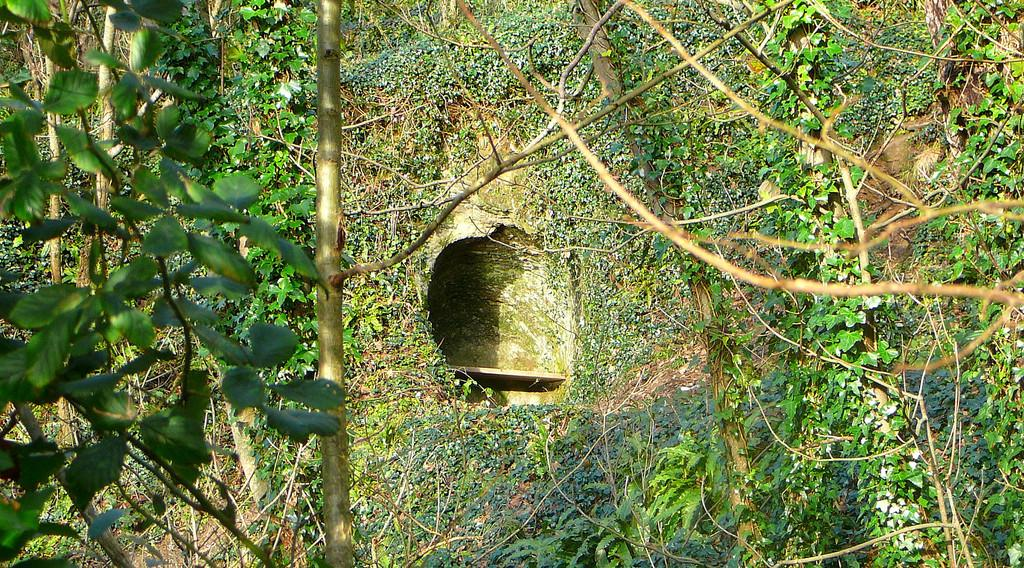What can be seen in the image? There is an object in the image. Can you describe the object? Unfortunately, the facts provided do not give enough information to describe the object. What else is visible in the image besides the object? There is a passage and trees on both the left and right sides of the image. What type of berry is hanging from the trees on the left side of the image? There is no mention of berries in the provided facts, and therefore we cannot determine if any berries are present in the image. 